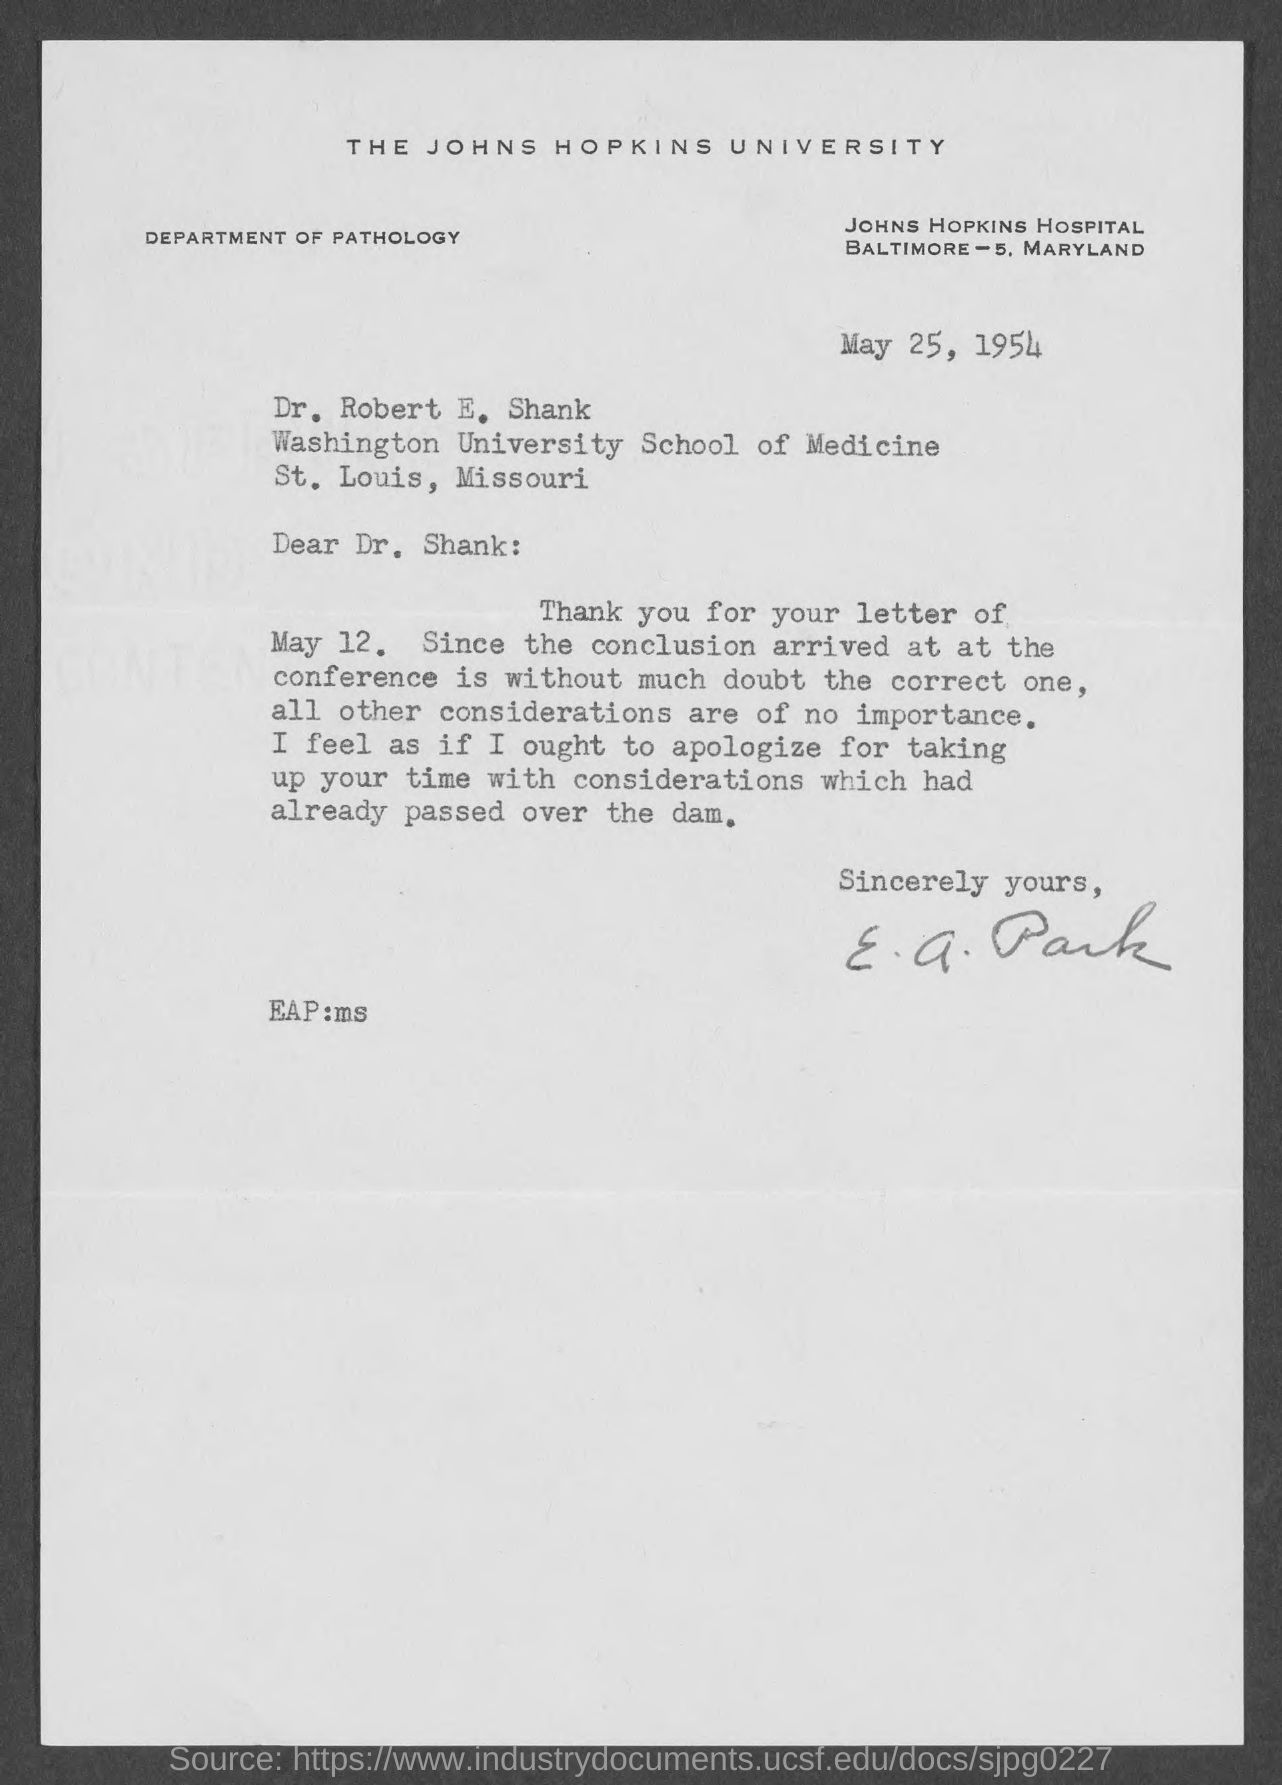Which University is mentioned in the letter head?
Your response must be concise. The Johns Hopkins University. What is the issued date of this letter?
Keep it short and to the point. May 25, 1954. Who is the sender of this letter?
Provide a succinct answer. E. A. Park. 